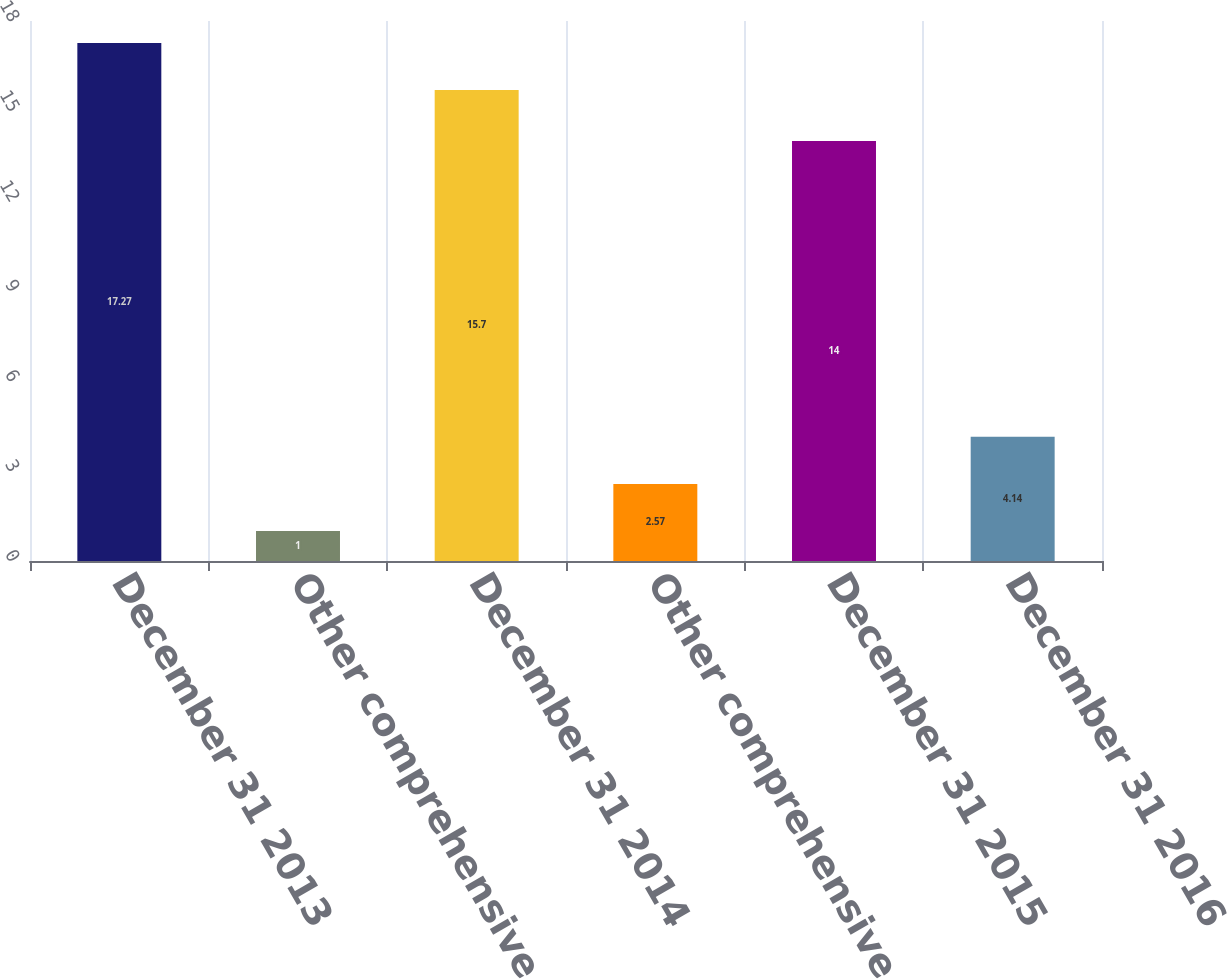Convert chart to OTSL. <chart><loc_0><loc_0><loc_500><loc_500><bar_chart><fcel>December 31 2013<fcel>Other comprehensive income<fcel>December 31 2014<fcel>Other comprehensive loss net<fcel>December 31 2015<fcel>December 31 2016<nl><fcel>17.27<fcel>1<fcel>15.7<fcel>2.57<fcel>14<fcel>4.14<nl></chart> 